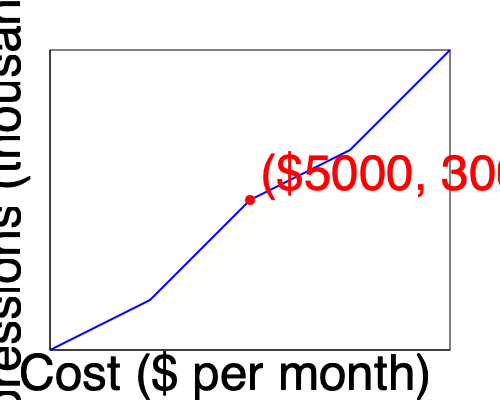Using the cost vs. impressions graph for billboard advertising, calculate the return on investment (ROI) for a $5000 monthly billboard campaign that generates 300,000 impressions. Assume each impression has a conversion rate of 0.1% and an average sale value of $250,000. Express your answer as a percentage. To calculate the ROI for the billboard advertising campaign, we'll follow these steps:

1. Identify the cost and impressions from the graph:
   Cost = $5000 per month
   Impressions = 300,000

2. Calculate the number of conversions:
   Conversion rate = 0.1% = 0.001
   Conversions = 300,000 * 0.001 = 300

3. Calculate the total revenue:
   Average sale value = $250,000
   Revenue = 300 * $250,000 = $75,000,000

4. Calculate the ROI using the formula:
   $$ ROI = \frac{\text{Revenue} - \text{Cost}}{\text{Cost}} \times 100\% $$

5. Plug in the values:
   $$ ROI = \frac{\$75,000,000 - \$5,000}{\$5,000} \times 100\% $$

6. Simplify:
   $$ ROI = \frac{\$74,995,000}{\$5,000} \times 100\% = 1,499,900\% $$

Therefore, the ROI for this billboard advertising campaign is 1,499,900%.
Answer: 1,499,900% 